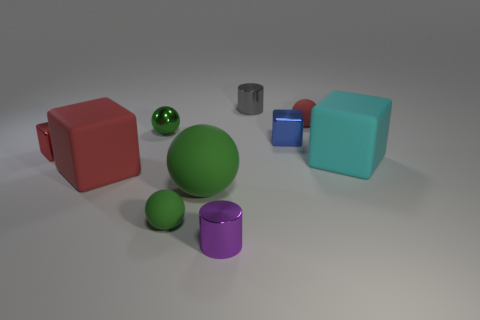Are there an equal number of cyan rubber things in front of the small metal ball and small green shiny things?
Your response must be concise. Yes. Is there anything else that is made of the same material as the cyan thing?
Your response must be concise. Yes. Do the big block that is in front of the large cyan matte block and the big cyan thing have the same material?
Provide a short and direct response. Yes. Is the number of green matte objects left of the tiny red shiny thing less than the number of small red matte spheres?
Your answer should be compact. Yes. How many metallic objects are either green things or large green objects?
Your response must be concise. 1. Does the big ball have the same color as the small shiny sphere?
Provide a short and direct response. Yes. Are there any other things that are the same color as the small shiny ball?
Your answer should be very brief. Yes. There is a small matte object in front of the tiny red sphere; does it have the same shape as the red matte object behind the big cyan rubber block?
Keep it short and to the point. Yes. What number of things are gray objects or cylinders that are right of the purple cylinder?
Offer a very short reply. 1. How many other objects are the same size as the cyan cube?
Offer a very short reply. 2. 